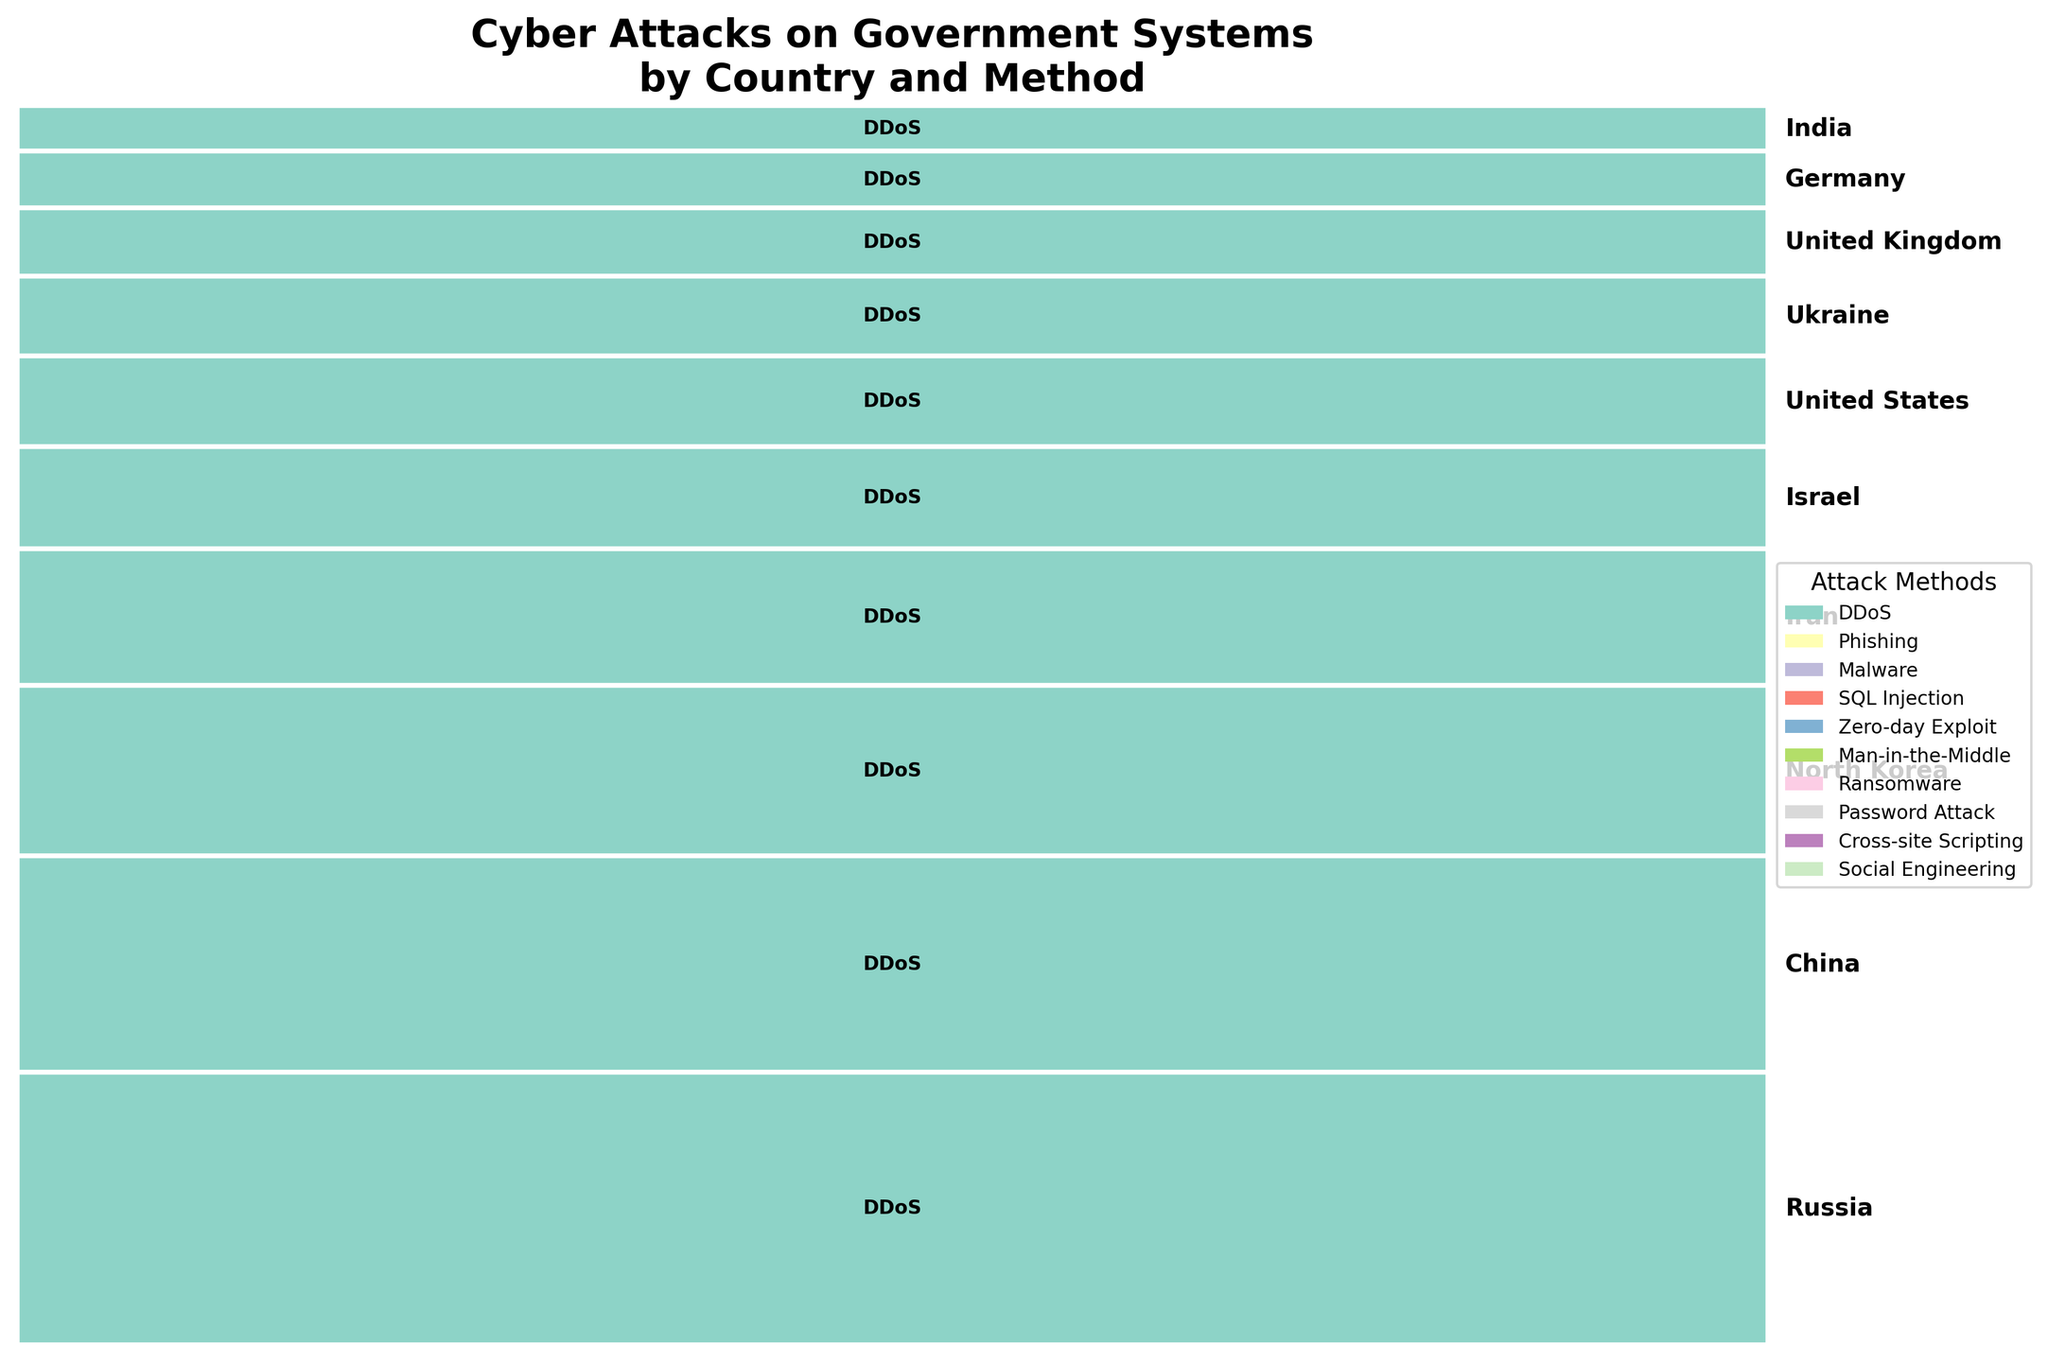What is the title of the plot? Look at the top of the plot where the title is typically placed and read the text.
Answer: Cyber Attacks on Government Systems by Country and Method How many countries are represented in the plot? Count the number of countries listed along the plot. Each country is marked with its name vertically on the right side of the plot.
Answer: 10 Which country has the highest frequency of cyber attacks? Find the country with the largest rectangle height. The height of the rectangle represents the frequency.
Answer: Russia Which country uses the Man-in-the-Middle attack most frequently? Look for the color-coded rectangles representing the Man-in-the-Middle attack and identify the country associated with the largest rectangle of that color.
Answer: United States What is the combined frequency of cyber attacks from Iran and Israel? Find the heights of the rectangles representing Iran and Israel. Add these values together. Iran (60) + Israel (45) = 105
Answer: 105 Which attack method is most frequently used by North Korea? Review the color-coded sections within North Korea's rectangle. The method with the largest width within that rectangle represents the most frequent attack method.
Answer: Malware How does the frequency of cyber attacks from Ukraine compare to those from Germany? Compare the heights of the rectangles representing Ukraine and Germany. The taller rectangle indicates a higher frequency of cyber attacks.
Answer: Ukraine has more Is the frequency of cyber attacks from China greater than that from India? Compare the heights of the rectangles for China and India. The taller rectangle has a higher frequency.
Answer: Yes Which country uses Social Engineering attacks? Find the color representing Social Engineering in the legend, then identify the country associated with that color-coded rectangle.
Answer: India What is the relative proportion of DDoS attacks from Russia compared to the total number of attacks? First, find the portion of the rectangle for Russia representing DDoS attacks, then compare this to the total height of all rectangles combined. 120 out of 545 (total frequency) = 120/545 = 0.2202 or 22.02%
Answer: 22.02% 